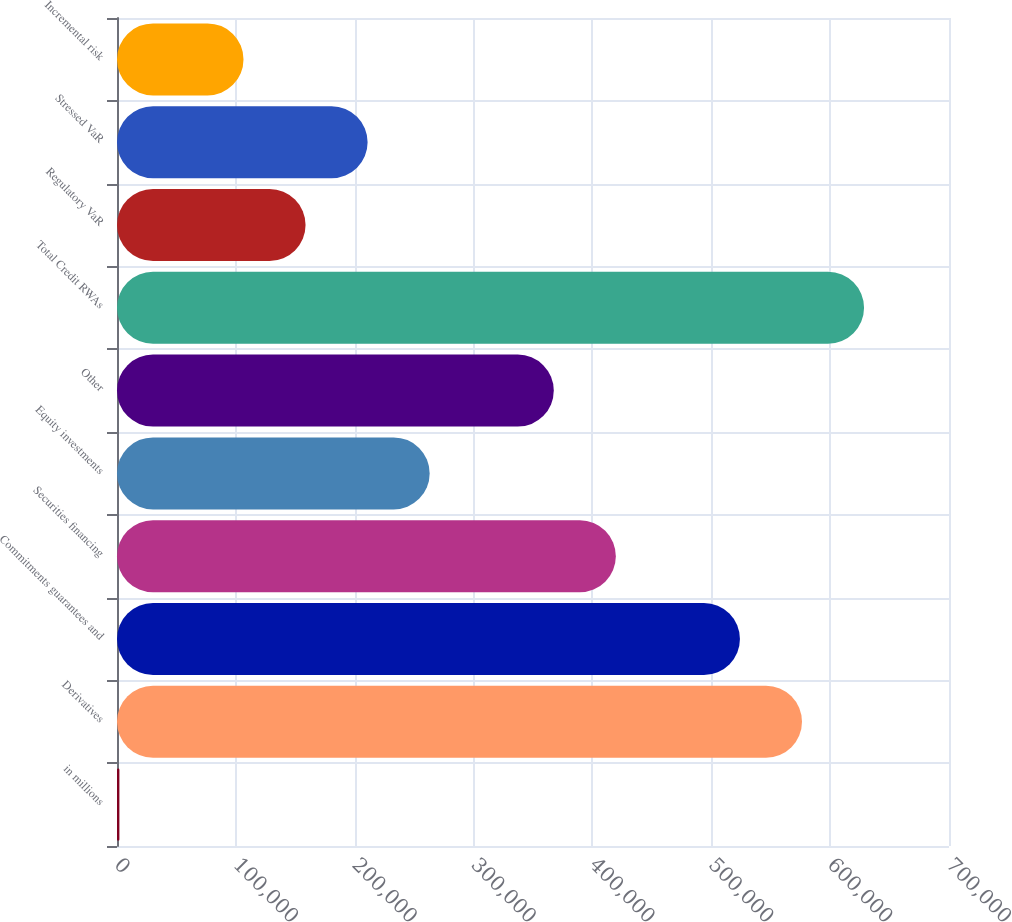<chart> <loc_0><loc_0><loc_500><loc_500><bar_chart><fcel>in millions<fcel>Derivatives<fcel>Commitments guarantees and<fcel>Securities financing<fcel>Equity investments<fcel>Other<fcel>Total Credit RWAs<fcel>Regulatory VaR<fcel>Stressed VaR<fcel>Incremental risk<nl><fcel>2015<fcel>576316<fcel>524107<fcel>419689<fcel>263061<fcel>367479<fcel>628525<fcel>158643<fcel>210852<fcel>106433<nl></chart> 